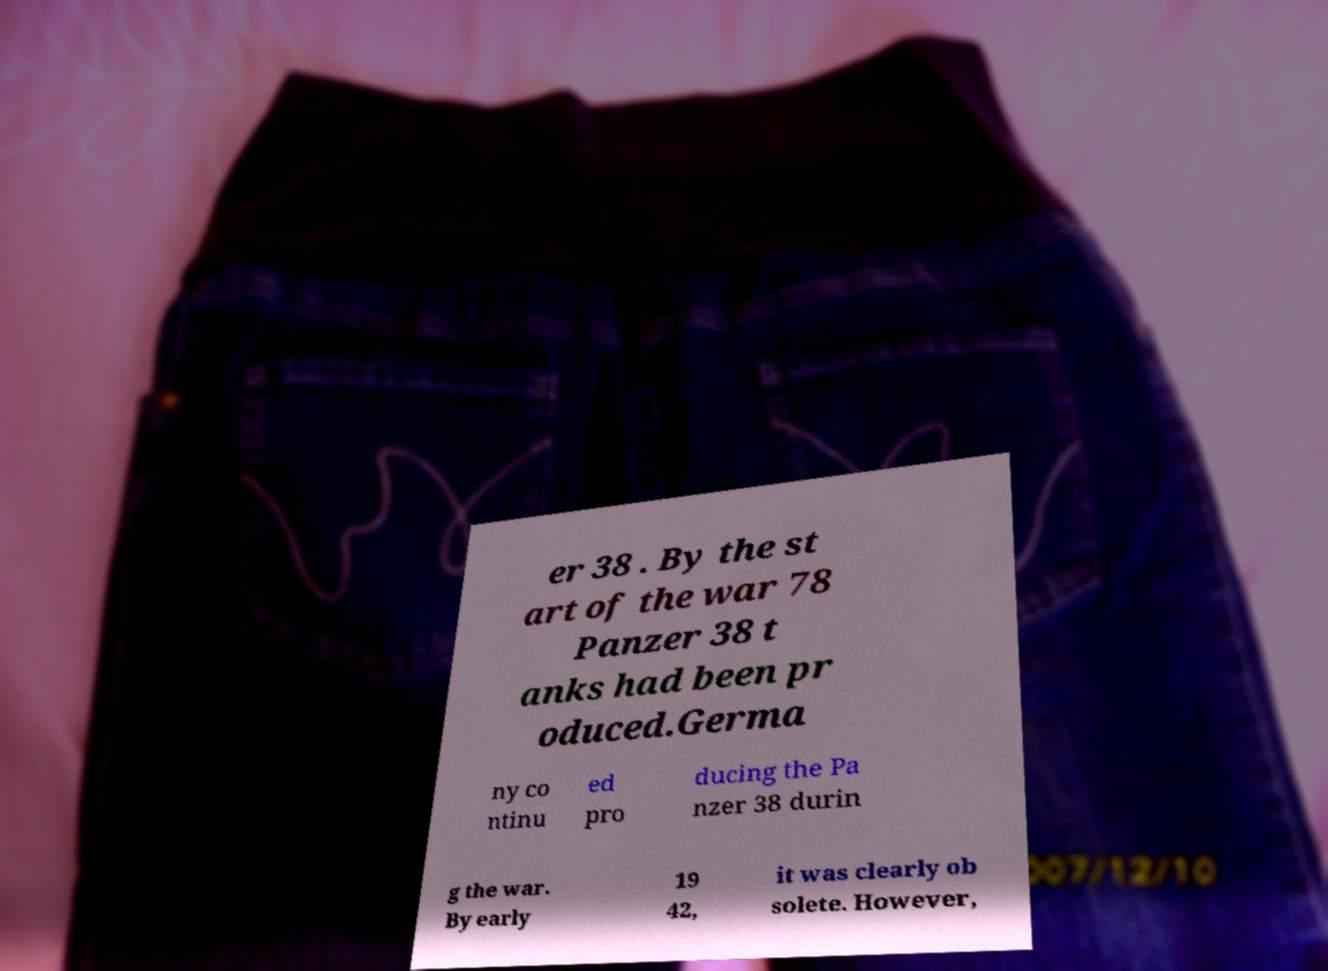Can you accurately transcribe the text from the provided image for me? er 38 . By the st art of the war 78 Panzer 38 t anks had been pr oduced.Germa ny co ntinu ed pro ducing the Pa nzer 38 durin g the war. By early 19 42, it was clearly ob solete. However, 